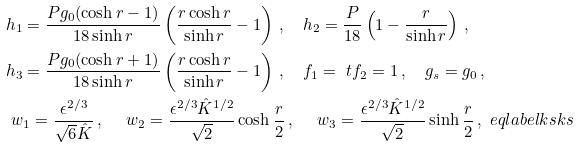Convert formula to latex. <formula><loc_0><loc_0><loc_500><loc_500>& h _ { 1 } = \frac { P g _ { 0 } ( \cosh r - 1 ) } { 1 8 \sinh r } \left ( \frac { r \cosh r } { \sinh r } - 1 \right ) \, , \quad h _ { 2 } = \frac { P } { 1 8 } \left ( 1 - \frac { r } { \sinh r } \right ) \, , \\ & h _ { 3 } = \frac { P g _ { 0 } ( \cosh r + 1 ) } { 1 8 \sinh r } \left ( \frac { r \cosh r } { \sinh r } - 1 \right ) \, , \quad f _ { 1 } = \ t f _ { 2 } = 1 \, , \quad g _ { s } = g _ { 0 } \, , \\ & \ w _ { 1 } = \frac { \epsilon ^ { 2 / 3 } } { \sqrt { 6 } { \hat { K } } } \, , \quad \ w _ { 2 } = \frac { \epsilon ^ { 2 / 3 } { \hat { K } } ^ { 1 / 2 } } { \sqrt { 2 } } \cosh \frac { r } { 2 } \, , \quad \ w _ { 3 } = \frac { \epsilon ^ { 2 / 3 } { \hat { K } } ^ { 1 / 2 } } { \sqrt { 2 } } \sinh \frac { r } { 2 } \, , \ e q l a b e l { k s k s }</formula> 